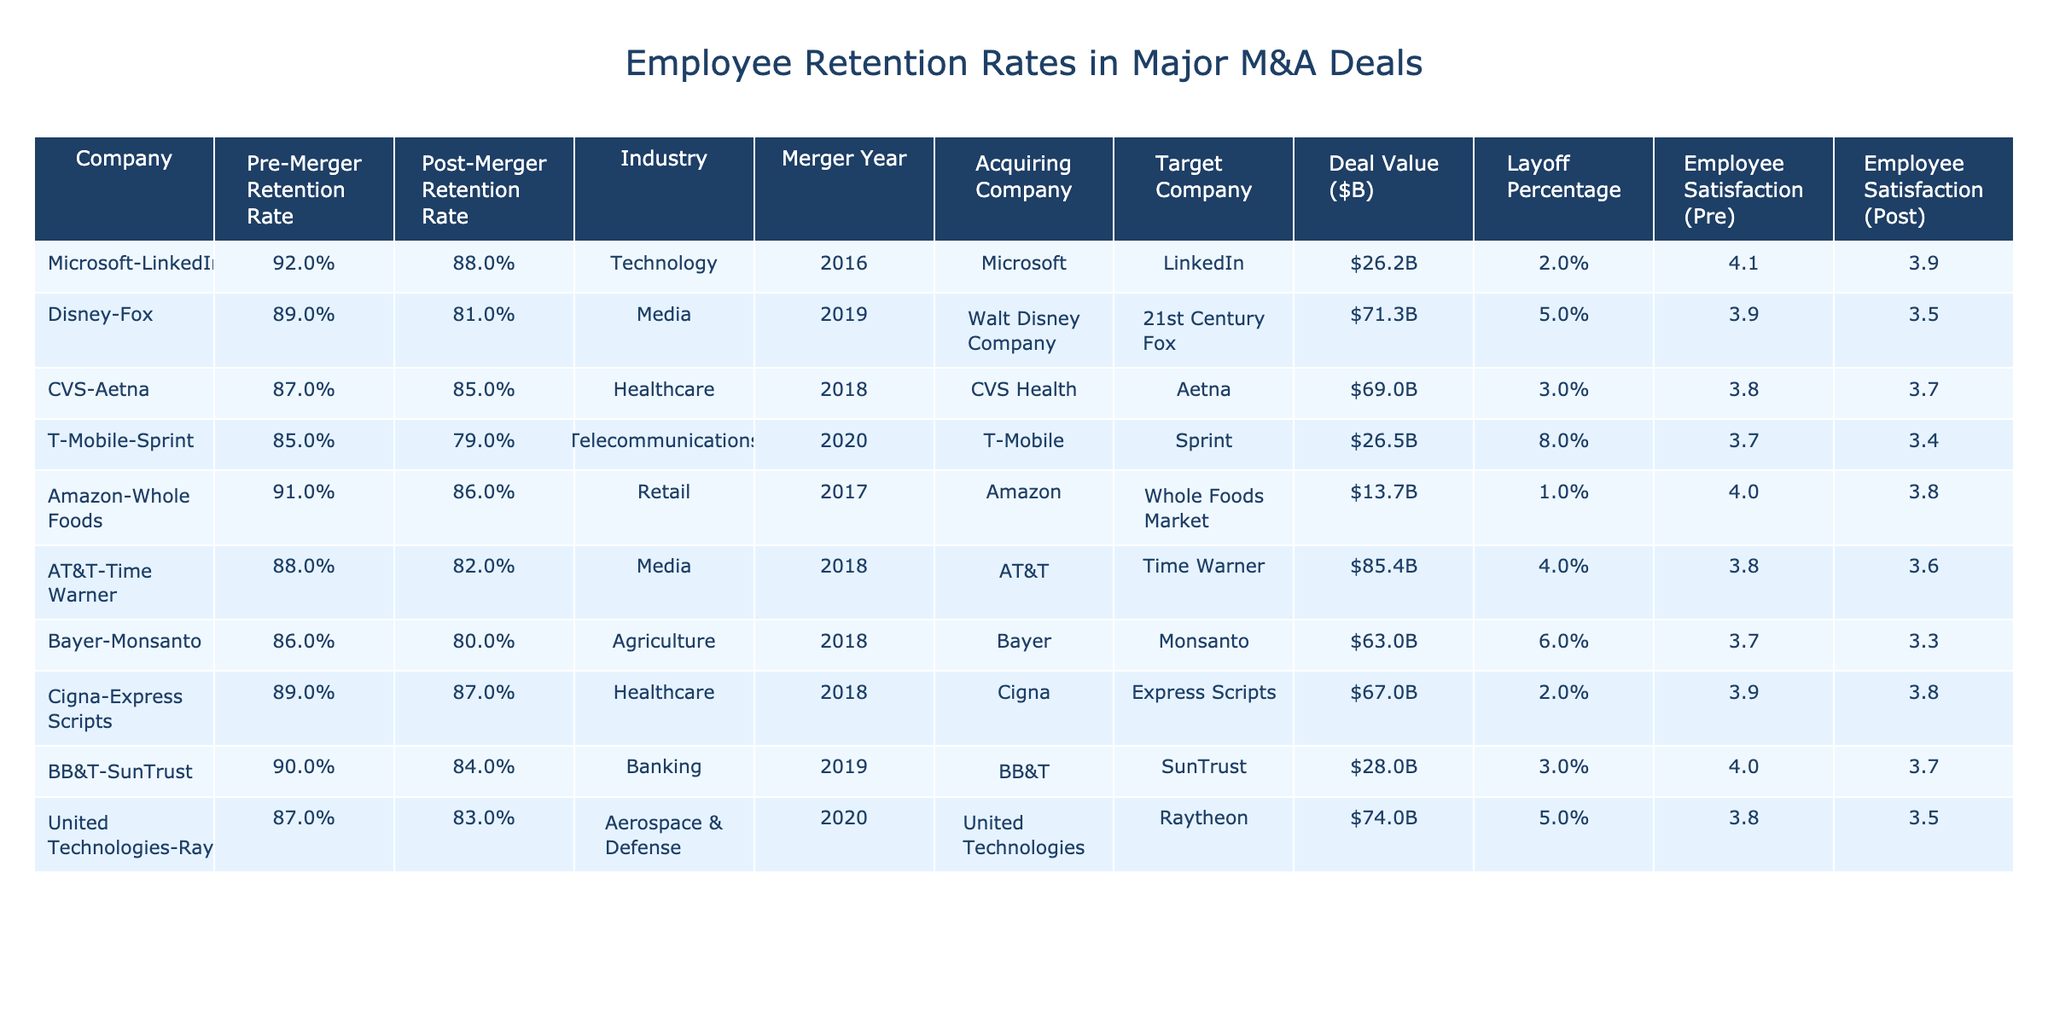What is the highest pre-merger retention rate among the companies? By examining the "Pre-Merger Retention Rate" column, I find the highest value is for Microsoft-LinkedIn at 92%.
Answer: 92% What is the post-merger retention rate for Disney-Fox? The "Post-Merger Retention Rate" for Disney-Fox is listed as 81%.
Answer: 81% Which company experienced the greatest layoff percentage after the merger? The "Layoff Percentage" column shows T-Mobile-Sprint with the highest rate at 8%.
Answer: 8% What was the deal value for the Amazon-Whole Foods merger? The "Deal Value ($B)" for Amazon-Whole Foods is $13.7 billion.
Answer: $13.7B How much did employee satisfaction drop on average across all companies after the mergers? First, I find the pre-merger average satisfaction as (4.1 + 3.9 + 3.8 + 3.7 + 4.0 + 3.8 + 3.7 + 3.9 + 4.0 + 3.8)/10 = 3.84. Next, I calculate the post-merger average satisfaction as (3.9 + 3.5 + 3.7 + 3.4 + 3.8 + 3.6 + 3.3 + 3.8 + 3.7 + 3.5)/10 = 3.57. Finally, the drop is 3.84 - 3.57 = 0.27.
Answer: 0.27 Is there a company where the post-merger retention rate increased compared to pre-merger? I check the retention rates for all companies and determine that Cigna-Express Scripts has a post-merger retention rate of 87%, which is higher than pre-merger at 89%. Therefore, no, it did not increase.
Answer: No Which company's merger involved the largest deal value? Looking at the "Deal Value ($B)" column, the largest amount is 85.4 billion for AT&T-Time Warner.
Answer: $85.4B What was the average pre-merger retention rate across all companies? To find the average, I sum the pre-merger rates (92 + 89 + 87 + 85 + 91 + 88 + 86 + 89 + 90 + 87) = 882. Then divide by 10 to get an average of 88.2%.
Answer: 88.2% Did the merger between Bayer and Monsanto have more layoffs than the merger between CVS and Aetna? Comparing the "Layoff Percentage" columns, Bayer-Monsanto reports a 6% layoff rate, and CVS-Aetna has a 3%. Since 6% > 3%, the answer is yes.
Answer: Yes What is the difference in employee satisfaction before and after the merger for T-Mobile-Sprint? The employee satisfaction before is 3.7 and after is 3.4. Therefore, the difference is 3.7 - 3.4 = 0.3.
Answer: 0.3 Which company has the highest post-merger employee satisfaction? Checking the "Employee Satisfaction (Post)" column, Microsoft-LinkedIn has the highest post-merger satisfaction at 3.9.
Answer: 3.9 